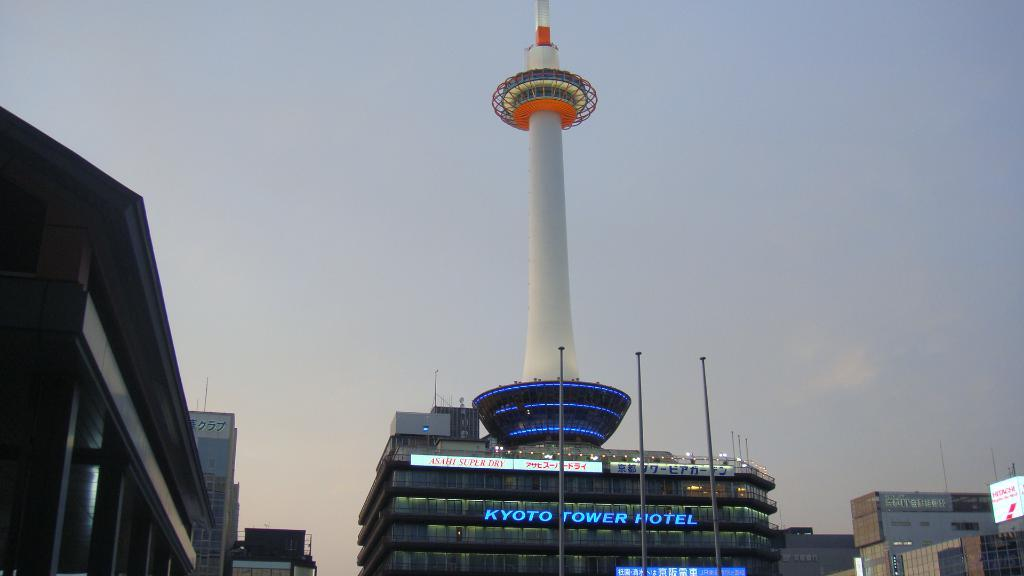What can be seen on the left side of the image? There are buildings on the left side of the image. What is present on the right side of the image? There are buildings, a tower, poles, and hoardings on the right side of the image. Can you describe the tower in the image? The tower is located on the right side of the image. What is visible in the background of the image? There are clouds in the blue sky in the background of the image. What type of shock can be seen affecting the buildings in the image? There is no shock present in the image; the buildings appear to be standing normally. Can you describe the screws used to hold the tower together in the image? There is no mention of screws in the image, and the tower's construction is not visible. 